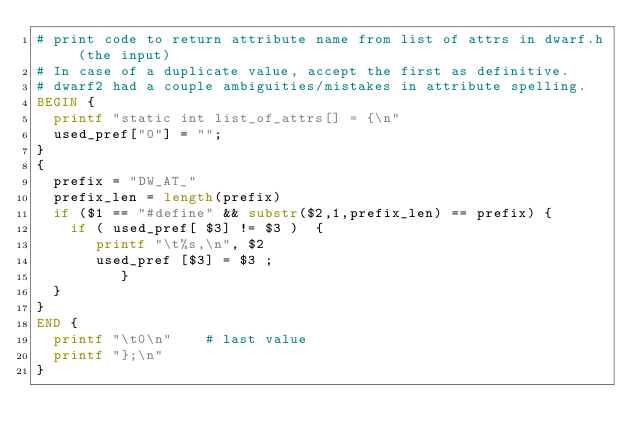Convert code to text. <code><loc_0><loc_0><loc_500><loc_500><_Awk_># print code to return attribute name from list of attrs in dwarf.h (the input)
# In case of a duplicate value, accept the first as definitive.
# dwarf2 had a couple ambiguities/mistakes in attribute spelling.
BEGIN {
	printf "static int list_of_attrs[] = {\n"
	used_pref["0"] = "";
}
{
	prefix = "DW_AT_"
	prefix_len = length(prefix)
	if ($1 == "#define" && substr($2,1,prefix_len) == prefix) {
		if ( used_pref[ $3] != $3 )  {
		   printf "\t%s,\n", $2
		   used_pref [$3] = $3 ;
	        }
	}
}
END {
	printf "\t0\n"		# last value
	printf "};\n"
}

</code> 